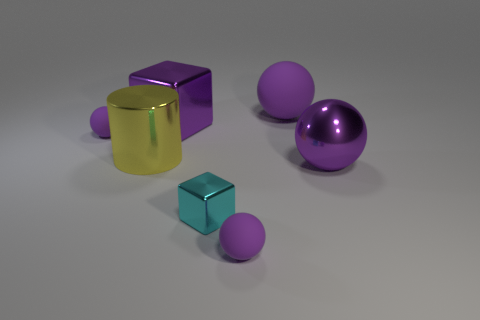There is a big yellow object that is the same material as the small cyan cube; what shape is it?
Your answer should be very brief. Cylinder. What number of small balls are right of the tiny sphere that is on the right side of the large yellow thing?
Offer a terse response. 0. How many rubber things are both in front of the purple metal block and right of the small metallic object?
Ensure brevity in your answer.  1. What number of other things are the same material as the cyan block?
Give a very brief answer. 3. There is a large sphere that is left of the big purple shiny object that is on the right side of the purple cube; what color is it?
Give a very brief answer. Purple. Do the thing that is on the right side of the large rubber object and the small metal block have the same color?
Ensure brevity in your answer.  No. Is the size of the cyan thing the same as the yellow metallic cylinder?
Your response must be concise. No. What shape is the other matte object that is the same size as the yellow object?
Make the answer very short. Sphere. Do the purple rubber ball in front of the purple metallic sphere and the small metallic thing have the same size?
Make the answer very short. Yes. There is a purple cube that is the same size as the yellow object; what is it made of?
Offer a terse response. Metal. 